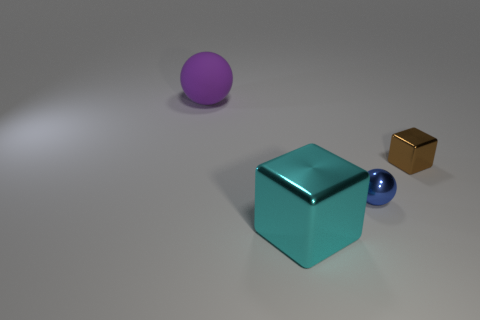There is a ball that is on the right side of the matte ball; how many brown cubes are in front of it?
Keep it short and to the point. 0. What number of objects are behind the small sphere and in front of the matte thing?
Offer a terse response. 1. What number of objects are either large objects or big objects in front of the tiny brown shiny cube?
Provide a short and direct response. 2. There is a ball that is made of the same material as the large cyan block; what is its size?
Provide a succinct answer. Small. What shape is the tiny object right of the tiny blue ball behind the big cyan cube?
Provide a succinct answer. Cube. What number of yellow objects are either metal balls or large matte spheres?
Your response must be concise. 0. There is a ball to the left of the shiny object on the left side of the blue metallic thing; are there any large balls that are to the left of it?
Your response must be concise. No. Is there any other thing that has the same material as the purple thing?
Keep it short and to the point. No. How many big objects are either cyan metallic things or purple metallic balls?
Keep it short and to the point. 1. There is a small thing behind the small blue sphere; does it have the same shape as the rubber object?
Keep it short and to the point. No. 